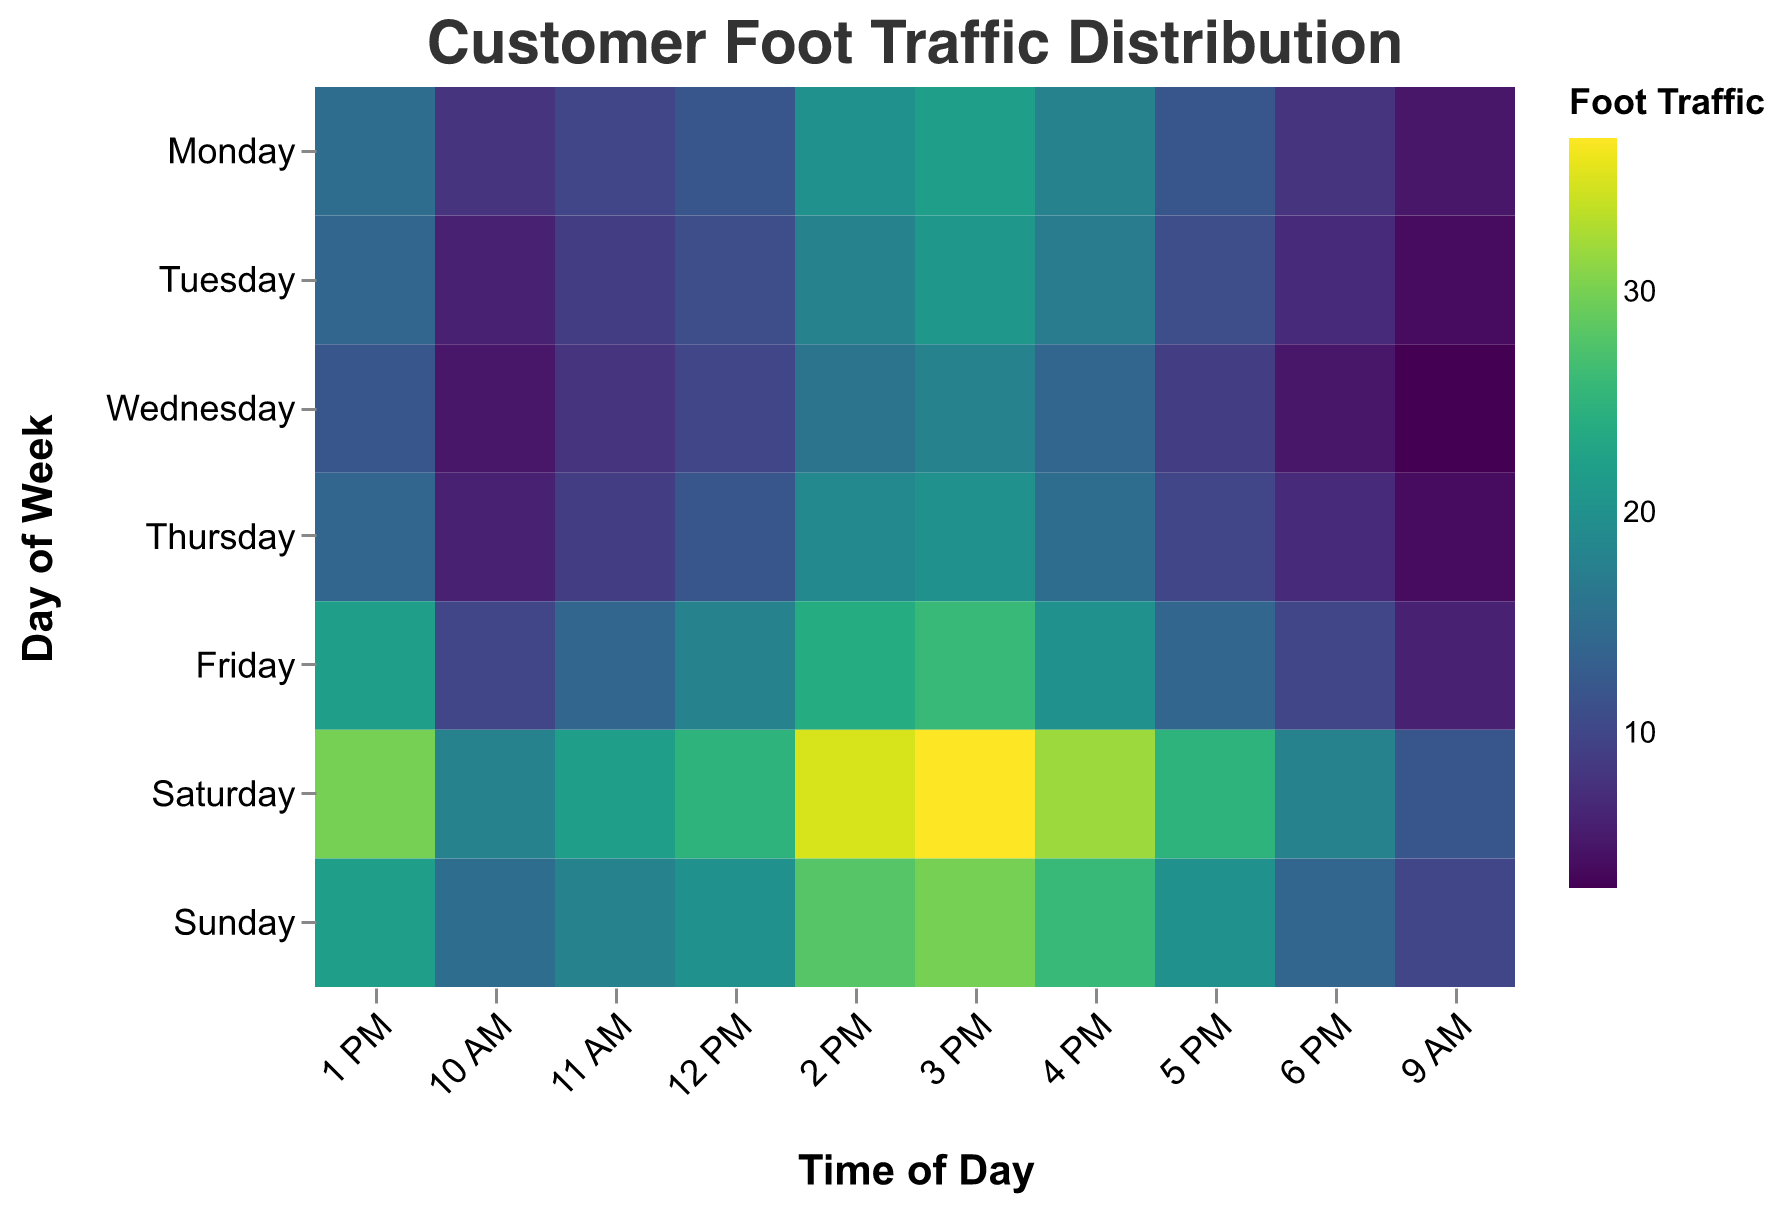How does foot traffic vary throughout the week? The heatmap shows the variation in foot traffic for each day and time slot. By looking at the different colors, we can see that weekends (Saturday and Sunday) generally have higher foot traffic compared to weekdays, especially in the afternoon. For weekdays, foot traffic tends to increase starting from 9 AM, peaks in the afternoon, and gradually decreases towards the evening.
Answer: Weekends are busier, especially in the afternoons Which day has the highest foot traffic at 2 PM? To find this, we can compare the color intensity corresponding to 2 PM across all days. Saturday shows the highest foot traffic at 2 PM with a value of 35.
Answer: Saturday What is the average foot traffic from 3 PM to 5 PM on Friday? To calculate this, we refer to the color intensities at 3 PM, 4 PM, and 5 PM on Friday, which are 26, 20, and 14 respectively. Summing these values gives 60, and the average is 60 divided by 3.
Answer: 20 Which time slot has the lowest foot traffic on Wednesday? By scanning the Wednesday row for the lightest color (lowest value), we find that 9 AM has the lowest foot traffic with a value of 3.
Answer: 9 AM How does foot traffic at 11 AM on Monday compare to 11 AM on Wednesday? By looking at the color intensity for 11 AM on both days, Monday has 10 and Wednesday has 8. Therefore, Monday has a higher foot traffic at 11 AM compared to Wednesday.
Answer: Higher on Monday What is the total foot traffic on Sunday? We need to sum the foot traffic values for all time slots on Sunday: 10 + 15 + 18 + 20 + 22 + 28 + 30 + 26 + 20 + 14. This adds up to 203.
Answer: 203 Which period shows the largest increase in foot traffic from one hour to the next on any day? By looking at the sharpest change in color gradient over hourly intervals for each day, the period from 1 PM to 2 PM on Saturday shows a significant increase from 30 to 35.
Answer: 1 PM to 2 PM on Saturday Is there any day where the foot traffic remains relatively stable throughout the day? By observing the row colors for each day, Tuesday shows a relatively steady increase without sharp changes, especially compared to other days.
Answer: Tuesday What is the median foot traffic value for Monday? Arranging the values for Monday in ascending order: 5, 8, 8, 10, 12, 12, 15, 18, 20, 22. The median value (middle-most) can be found by averaging the 5th and 6th values: (12+12)/2.
Answer: 12 